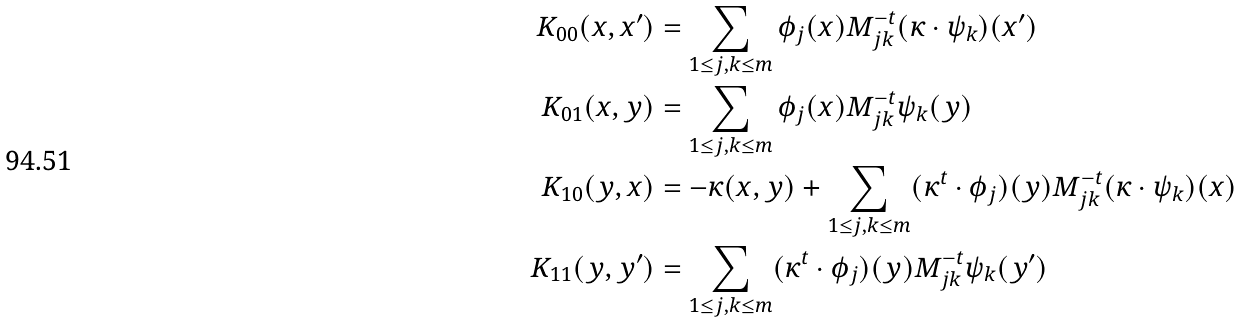<formula> <loc_0><loc_0><loc_500><loc_500>K _ { 0 0 } ( x , x ^ { \prime } ) & = \sum _ { 1 \leq j , k \leq m } \phi _ { j } ( x ) M ^ { - t } _ { j k } ( \kappa \cdot \psi _ { k } ) ( x ^ { \prime } ) \\ K _ { 0 1 } ( x , y ) & = \sum _ { 1 \leq j , k \leq m } \phi _ { j } ( x ) M ^ { - t } _ { j k } \psi _ { k } ( y ) \\ K _ { 1 0 } ( y , x ) & = - \kappa ( x , y ) + \sum _ { 1 \leq j , k \leq m } ( \kappa ^ { t } \cdot \phi _ { j } ) ( y ) M ^ { - t } _ { j k } ( \kappa \cdot \psi _ { k } ) ( x ) \\ K _ { 1 1 } ( y , y ^ { \prime } ) & = \sum _ { 1 \leq j , k \leq m } ( \kappa ^ { t } \cdot \phi _ { j } ) ( y ) M ^ { - t } _ { j k } \psi _ { k } ( y ^ { \prime } )</formula> 